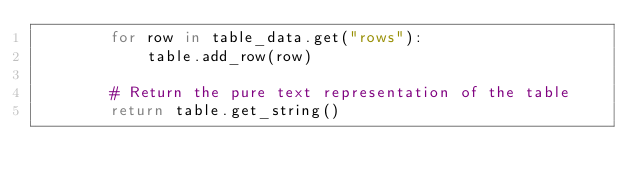Convert code to text. <code><loc_0><loc_0><loc_500><loc_500><_Python_>        for row in table_data.get("rows"):
            table.add_row(row)

        # Return the pure text representation of the table
        return table.get_string()
</code> 